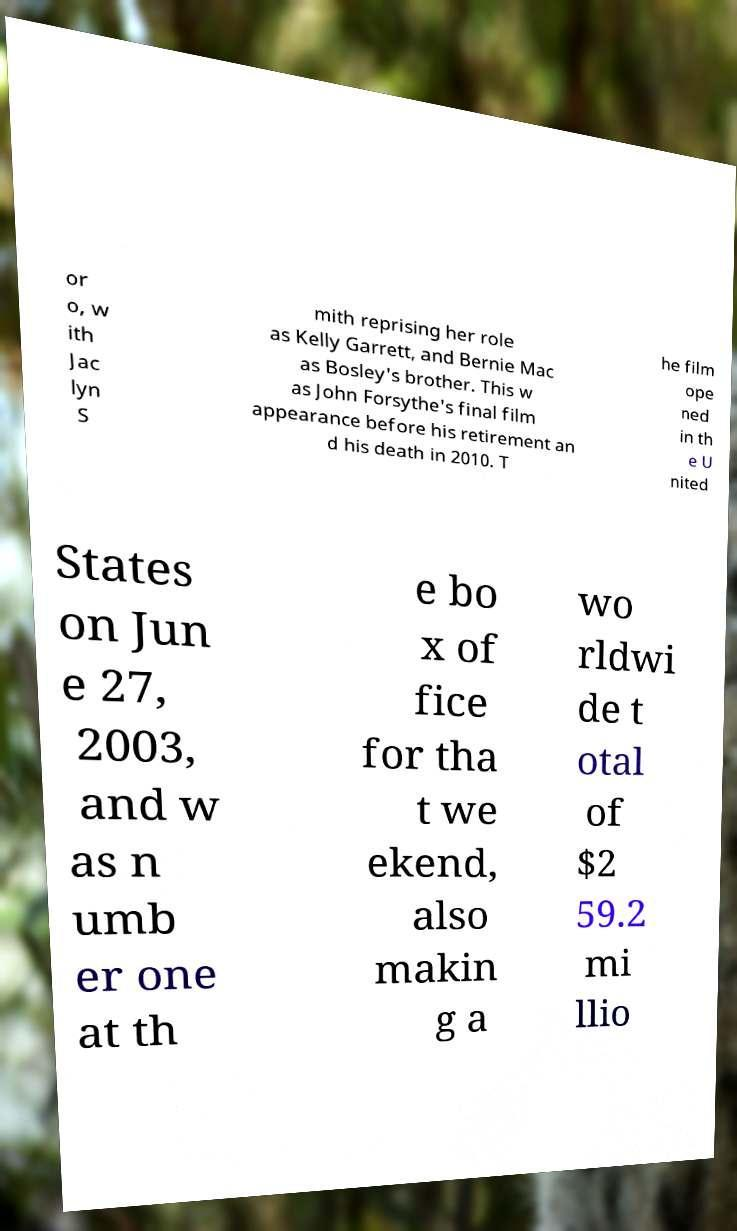Can you accurately transcribe the text from the provided image for me? or o, w ith Jac lyn S mith reprising her role as Kelly Garrett, and Bernie Mac as Bosley's brother. This w as John Forsythe's final film appearance before his retirement an d his death in 2010. T he film ope ned in th e U nited States on Jun e 27, 2003, and w as n umb er one at th e bo x of fice for tha t we ekend, also makin g a wo rldwi de t otal of $2 59.2 mi llio 